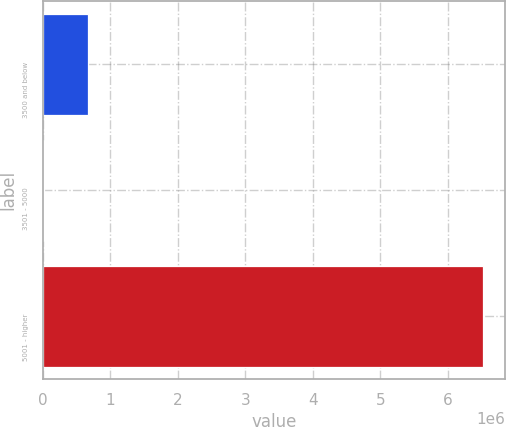<chart> <loc_0><loc_0><loc_500><loc_500><bar_chart><fcel>3500 and below<fcel>3501 - 5000<fcel>5001 - higher<nl><fcel>668301<fcel>17956<fcel>6.52141e+06<nl></chart> 